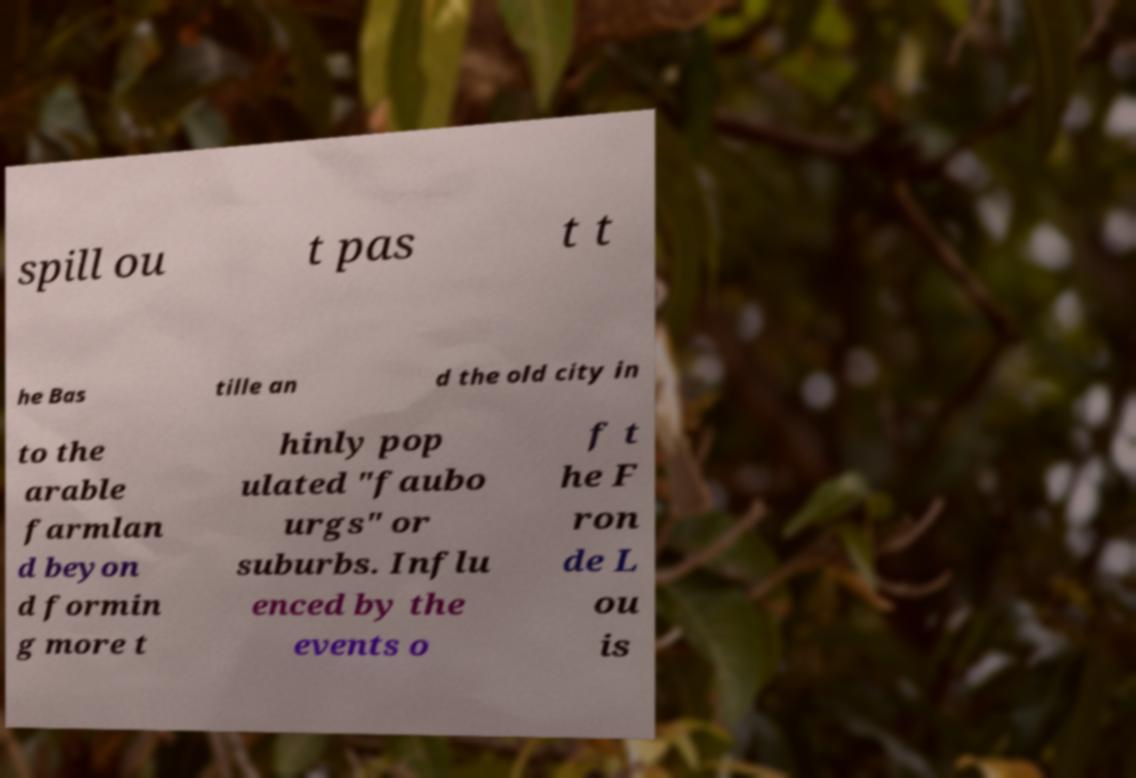Please read and relay the text visible in this image. What does it say? spill ou t pas t t he Bas tille an d the old city in to the arable farmlan d beyon d formin g more t hinly pop ulated "faubo urgs" or suburbs. Influ enced by the events o f t he F ron de L ou is 